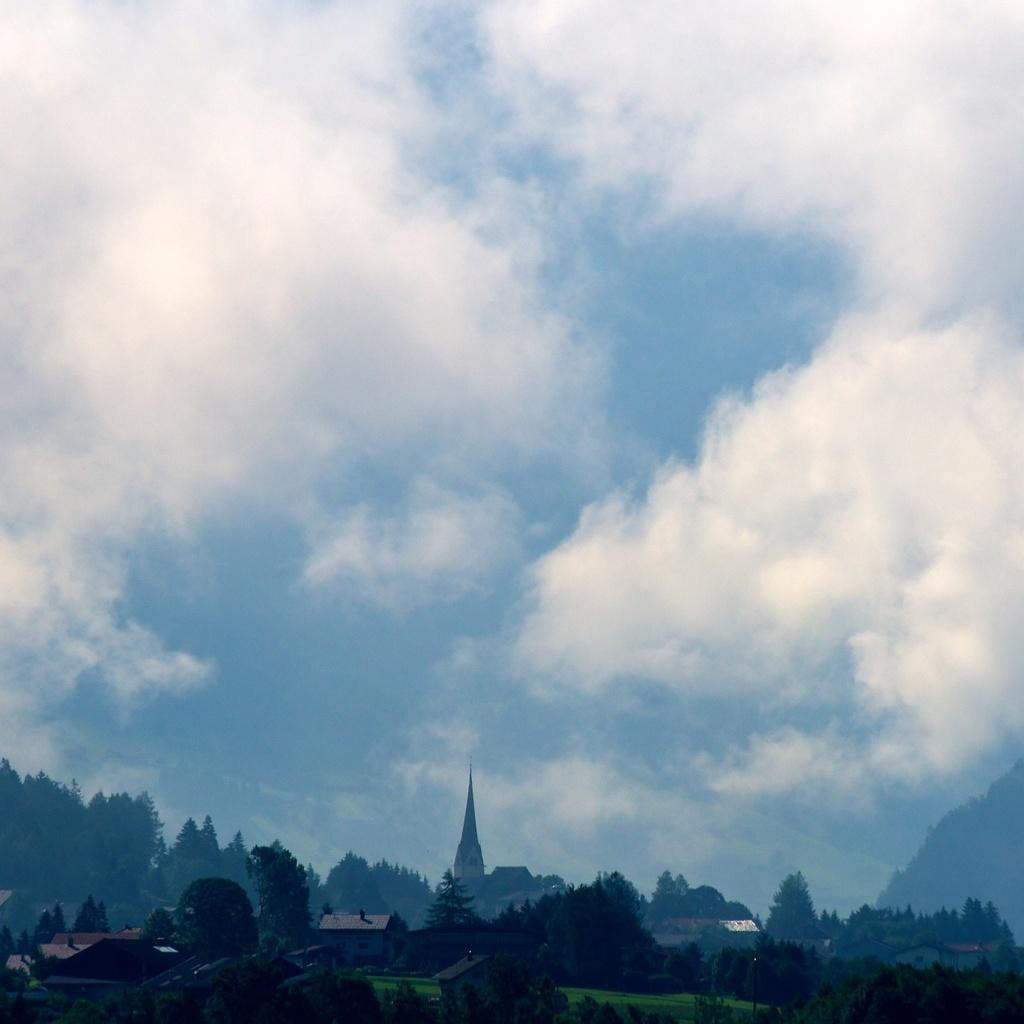What type of structures can be seen in the image? There are buildings in the image. What type of vegetation is present in the image? There are trees in the image. What type of ground cover is visible in the image? There is grass visible in the image. What can be seen in the sky in the image? There are clouds in the sky. How many passengers are on the farmer's tractor in the image? There is no farmer or tractor present in the image. 